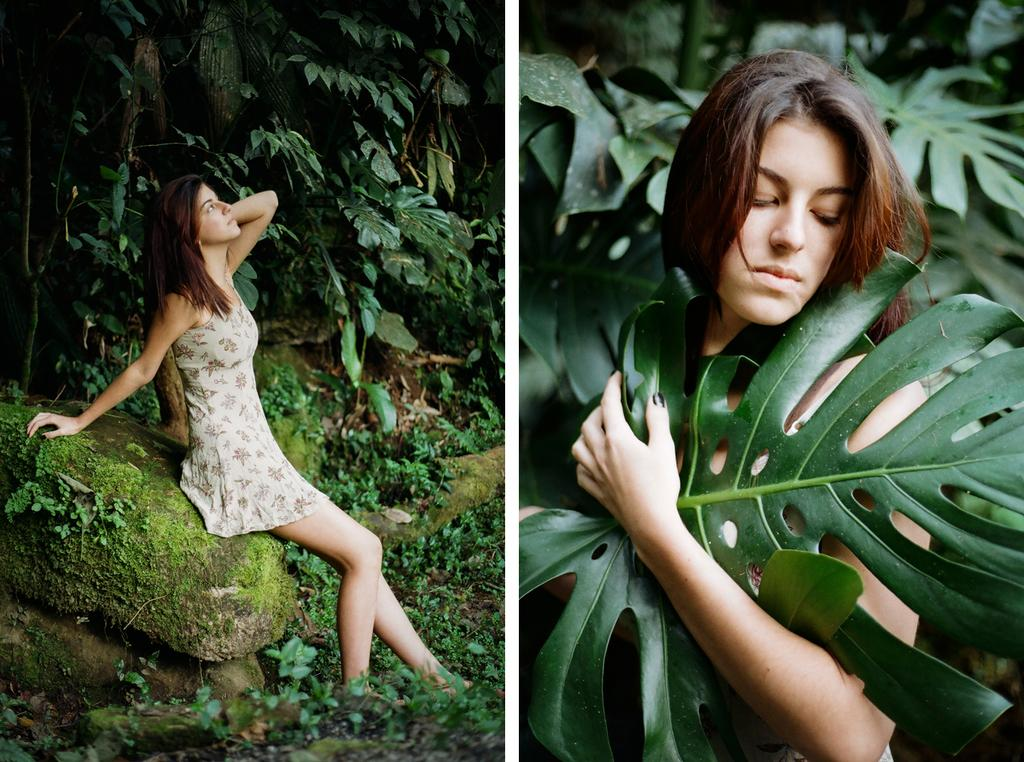How many women are in the image? There are two women in the image. What is one of the women doing in the image? One woman is sitting on a stone. What can be seen on the left side of the image? There are trees visible on the left side of the image. How many cattle can be seen grazing in the background of the image? There are no cattle visible in the image; it only features two women and trees on the left side. What is the grandmother doing in the image? There is no mention of a grandmother in the image, as it only features two women. 